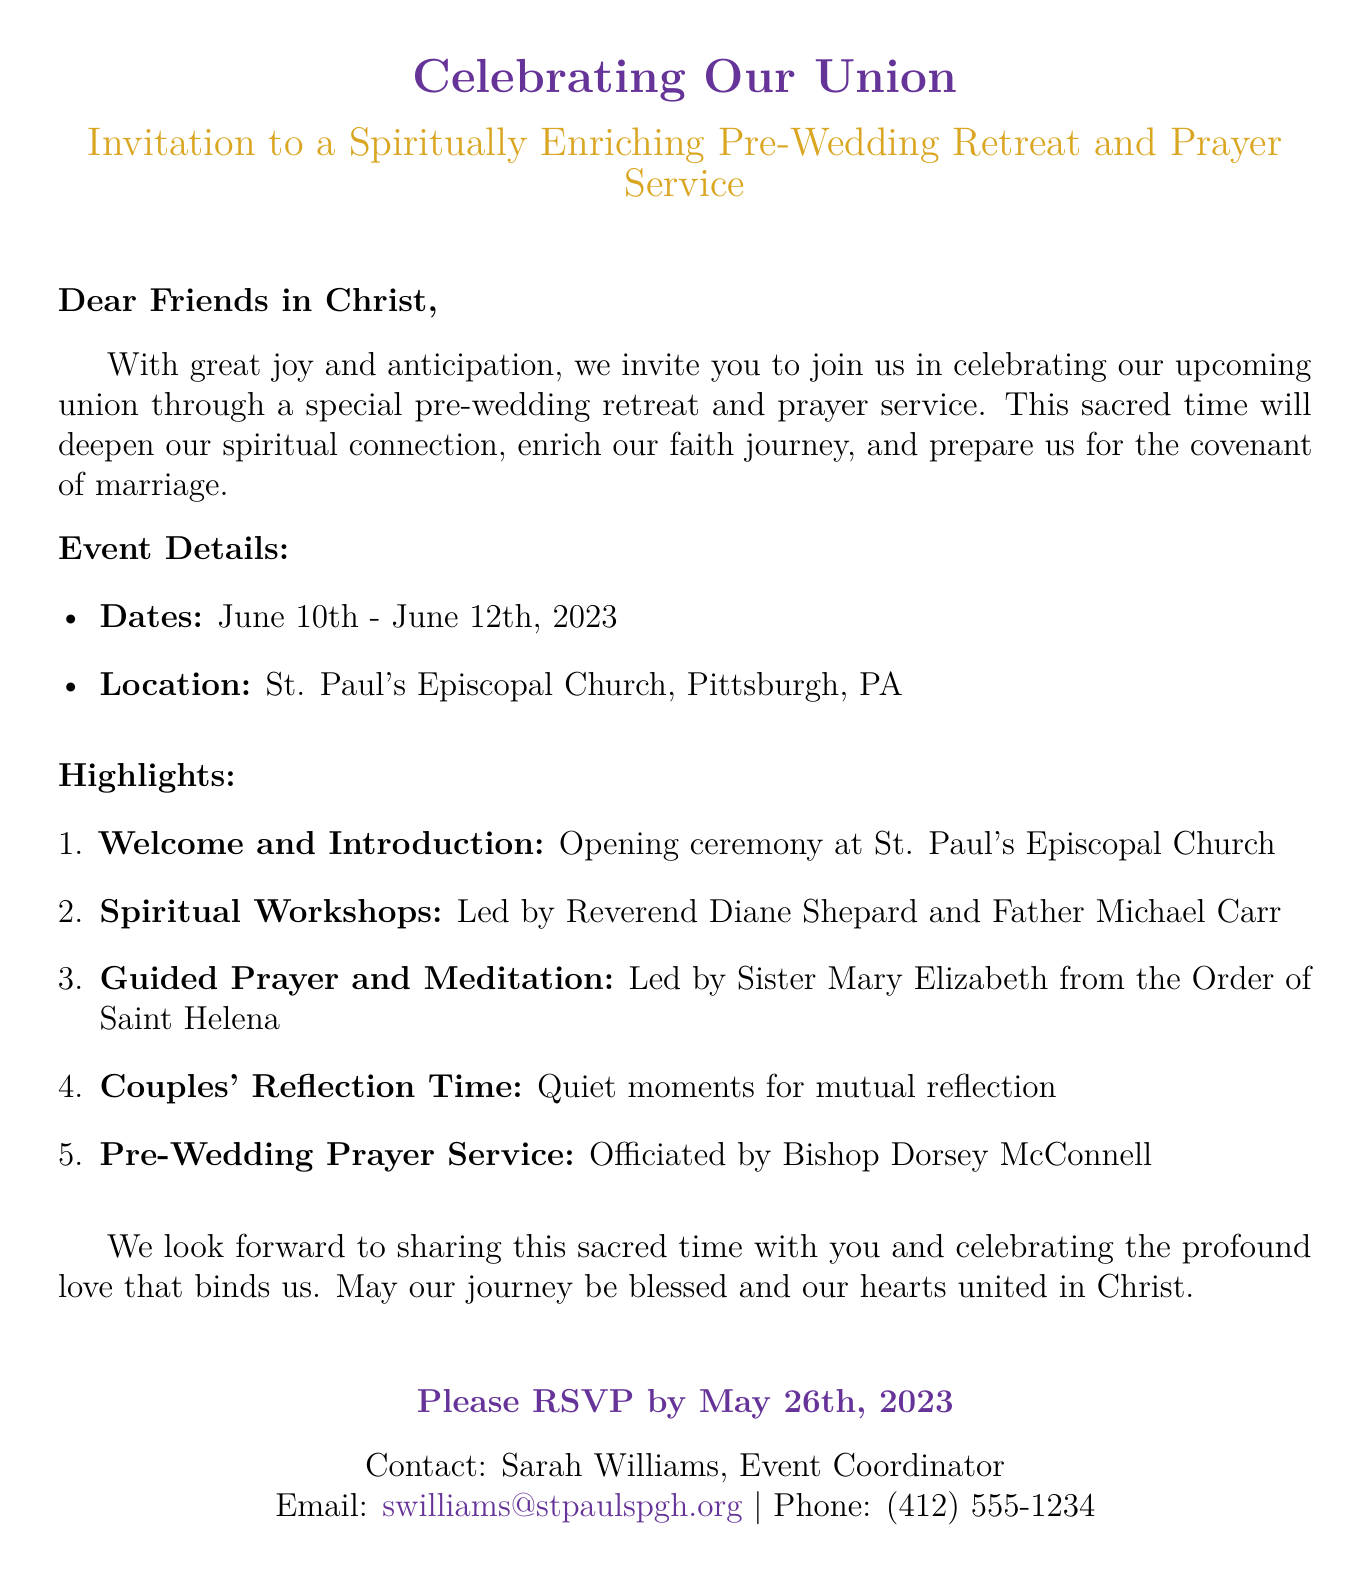What are the dates of the retreat? The dates of the retreat are clearly specified in the document as June 10th - June 12th, 2023.
Answer: June 10th - June 12th, 2023 Who is the event coordinator? The document mentions Sarah Williams as the contact person for the event, specifically as the Event Coordinator.
Answer: Sarah Williams Where will the event take place? The location of the event is highlighted in the document as St. Paul's Episcopal Church, Pittsburgh, PA.
Answer: St. Paul's Episcopal Church, Pittsburgh, PA What is one of the highlights of the retreat? The document lists multiple highlights of the retreat; one of them is "Guided Prayer and Meditation."
Answer: Guided Prayer and Meditation When is the RSVP deadline? The document states that guests should RSVP by May 26th, 2023.
Answer: May 26th, 2023 Who will officiate the Pre-Wedding Prayer Service? The officiant for the prayer service is specified in the document as Bishop Dorsey McConnell.
Answer: Bishop Dorsey McConnell What type of document is this? The document is an invitation specifically for a pre-wedding retreat and prayer service, which is unique to wedding celebrations.
Answer: Wedding invitation What color is associated with the event? The document uses "episcopalpurple" as a prominent color throughout the invitation, indicating its thematic importance.
Answer: episcopalpurple 